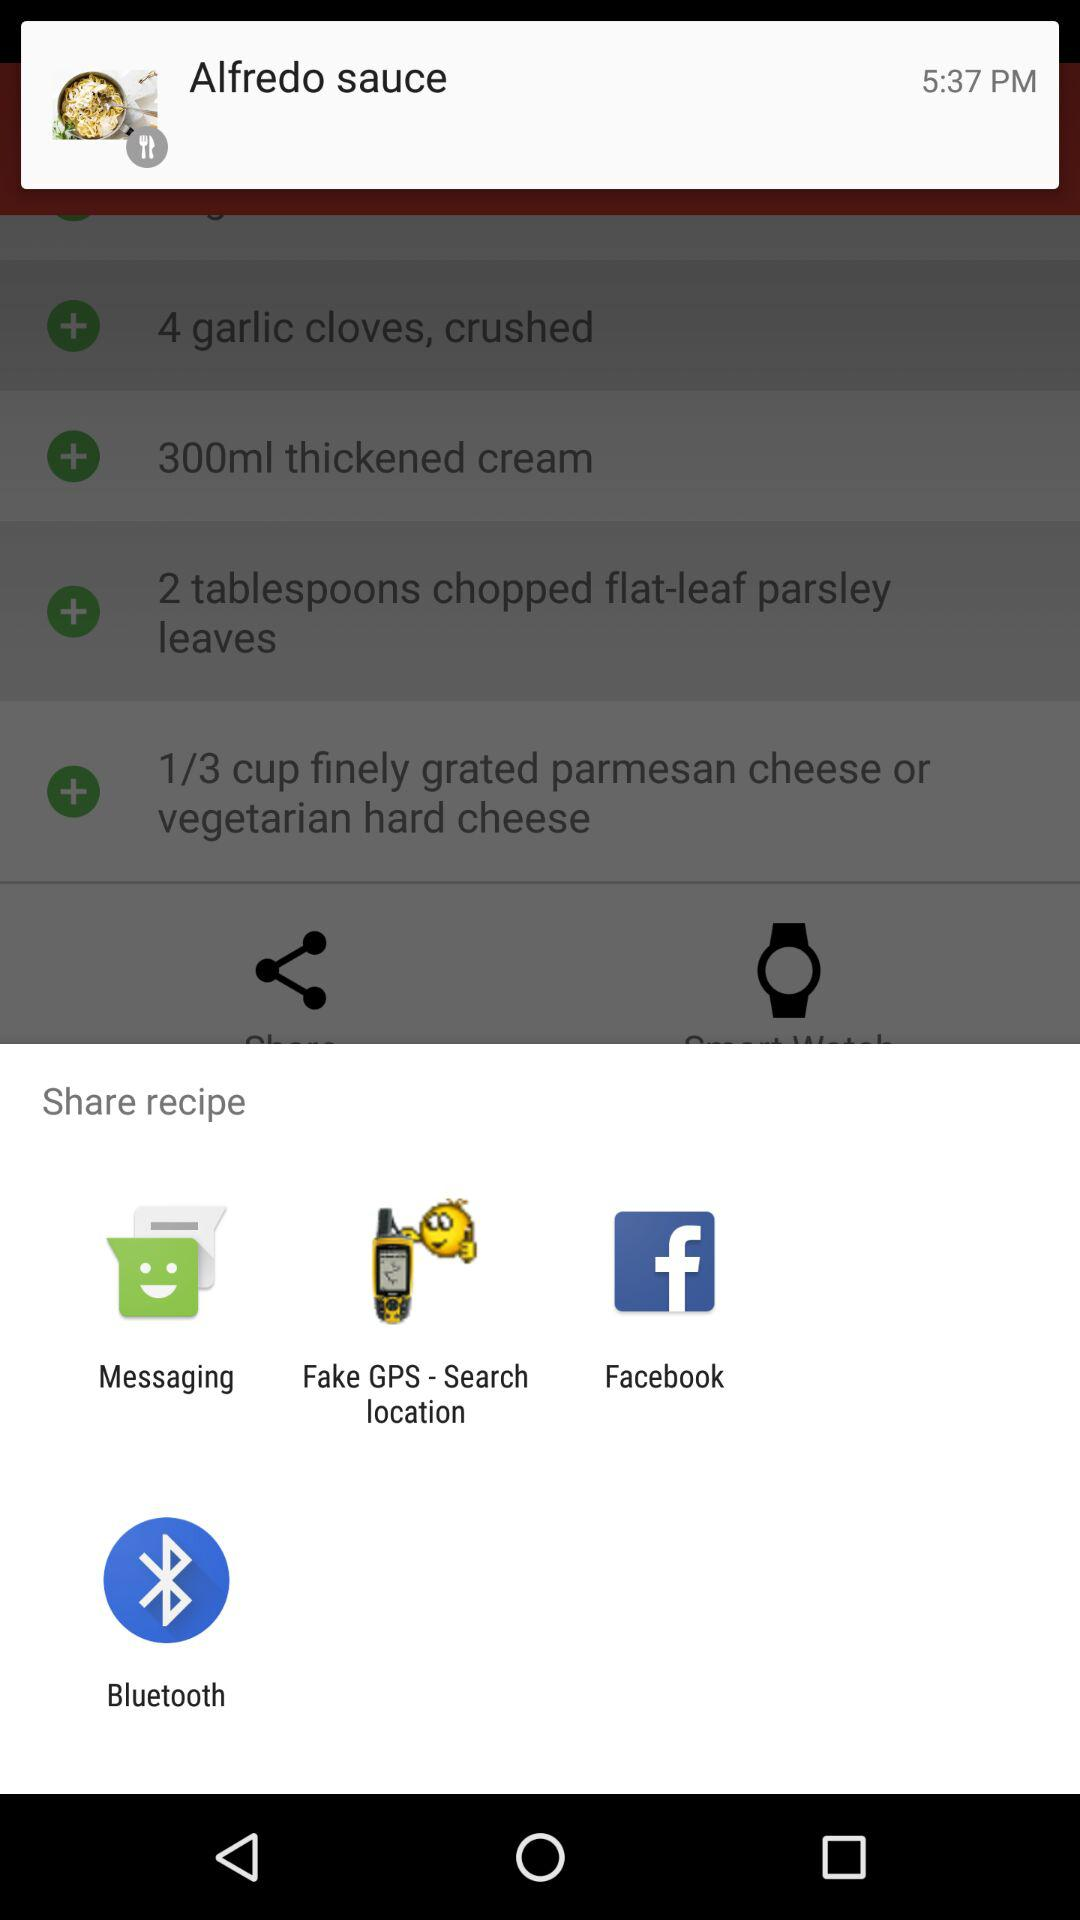What is the time? The time is 5:37 p.m. 